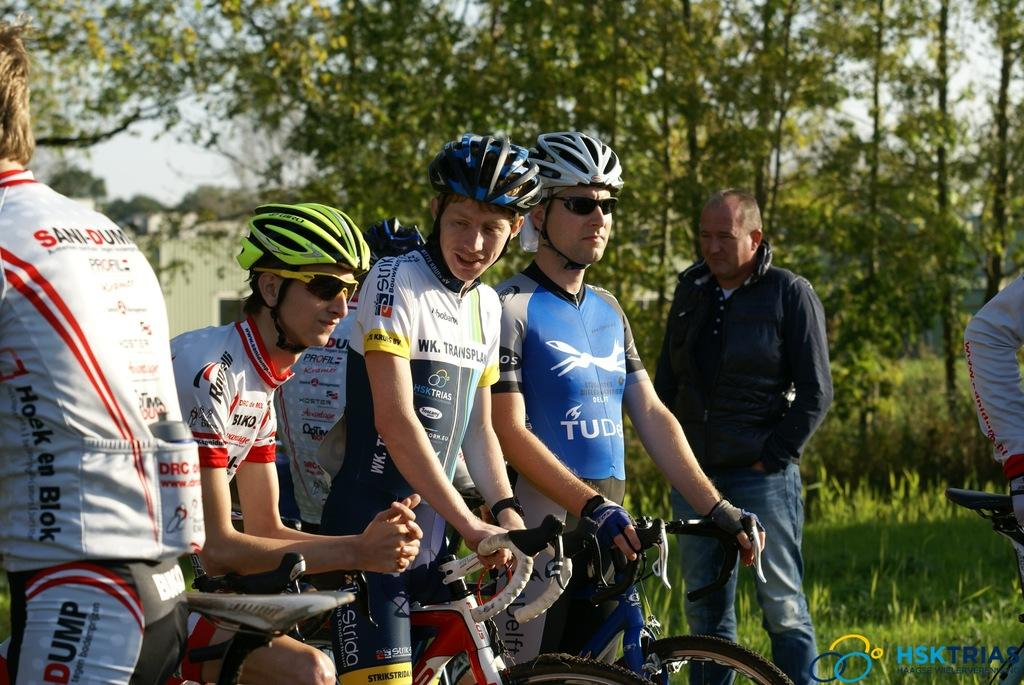What can be seen in the image? There are men in the image, and they are with cycles. What are the men wearing in the image? The men are wearing helmets in the image. What can be seen in the background of the image? There are trees and grass visible in the background of the image. What type of quartz can be seen in the image? There is no quartz present in the image. How does the shock of the cycle affect the men in the image? The image does not depict any shock or impact from the cycles, so it cannot be determined how the men might be affected. 